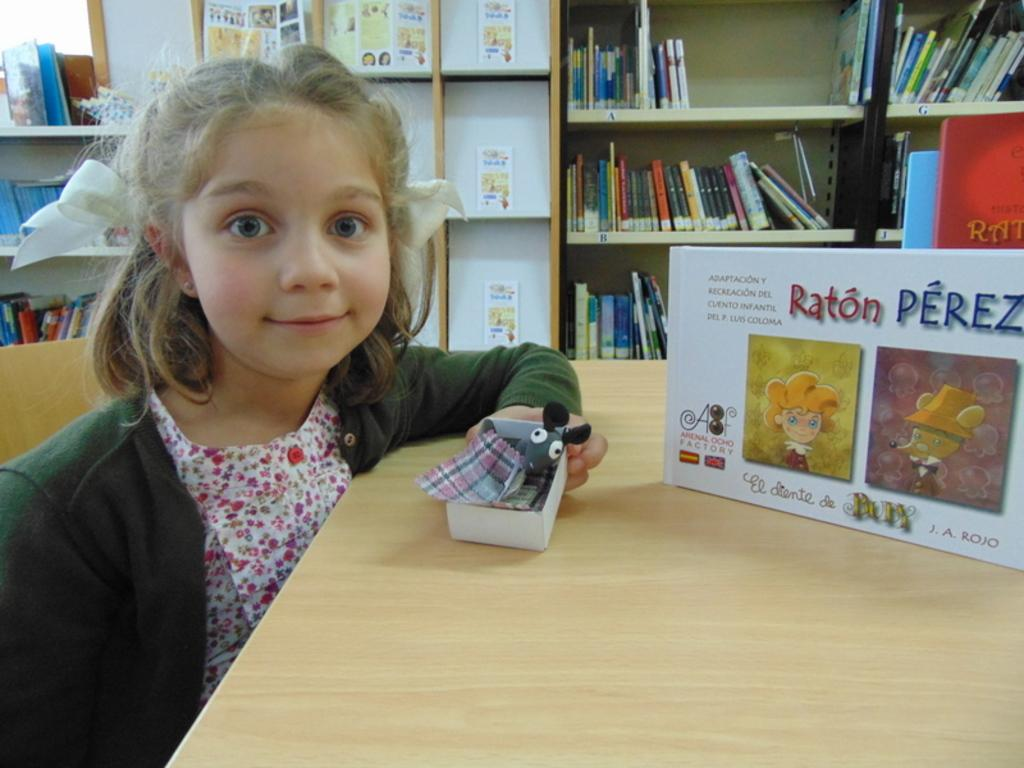<image>
Provide a brief description of the given image. A girl sits in front of a box that says "Raton PEREZ" and is holding a toy mouse in a box. 